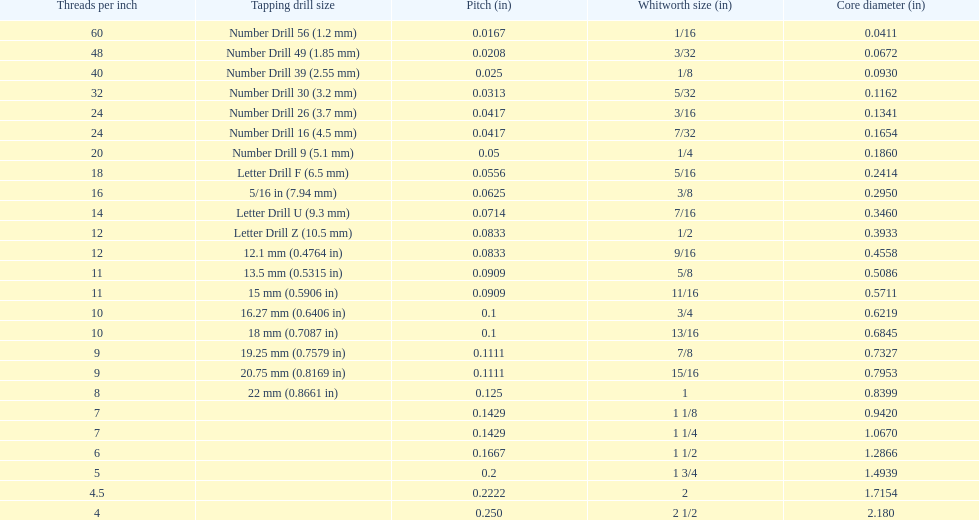What core diameter (in) comes after 0.0930? 0.1162. 